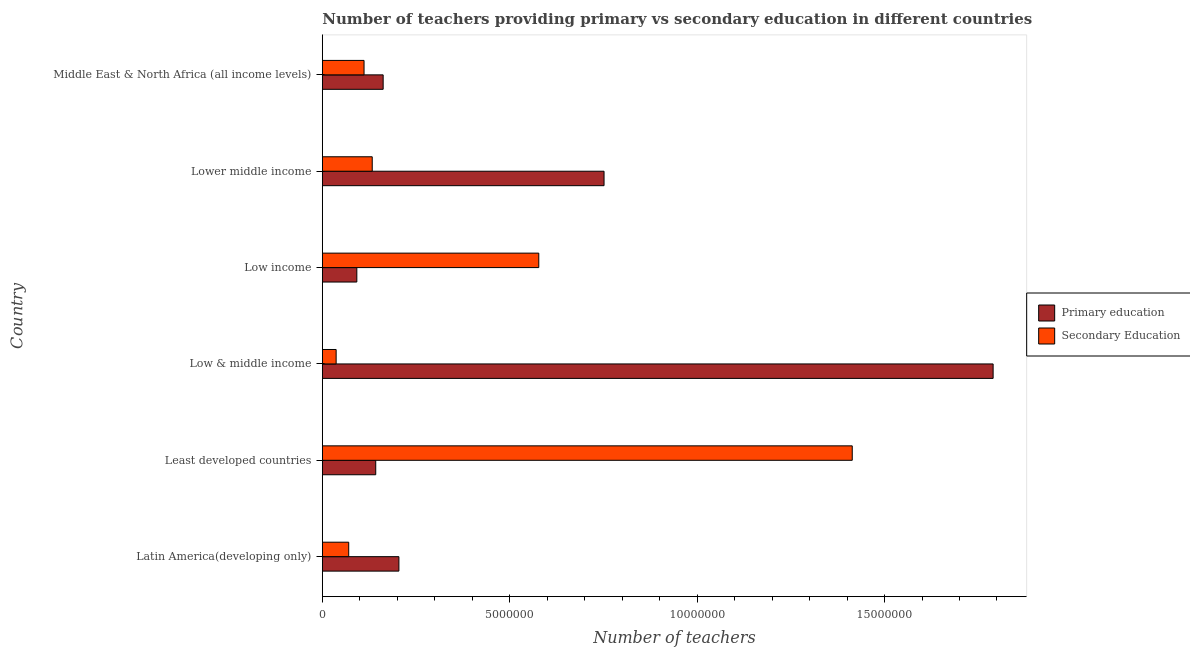How many different coloured bars are there?
Offer a terse response. 2. Are the number of bars on each tick of the Y-axis equal?
Make the answer very short. Yes. How many bars are there on the 3rd tick from the top?
Offer a very short reply. 2. How many bars are there on the 2nd tick from the bottom?
Make the answer very short. 2. What is the label of the 1st group of bars from the top?
Keep it short and to the point. Middle East & North Africa (all income levels). What is the number of primary teachers in Low & middle income?
Your response must be concise. 1.79e+07. Across all countries, what is the maximum number of secondary teachers?
Your answer should be very brief. 1.41e+07. Across all countries, what is the minimum number of secondary teachers?
Provide a short and direct response. 3.69e+05. In which country was the number of secondary teachers maximum?
Your response must be concise. Least developed countries. In which country was the number of secondary teachers minimum?
Give a very brief answer. Low & middle income. What is the total number of secondary teachers in the graph?
Keep it short and to the point. 2.34e+07. What is the difference between the number of primary teachers in Low & middle income and that in Middle East & North Africa (all income levels)?
Offer a very short reply. 1.63e+07. What is the difference between the number of primary teachers in Least developed countries and the number of secondary teachers in Lower middle income?
Keep it short and to the point. 9.36e+04. What is the average number of secondary teachers per country?
Provide a short and direct response. 3.91e+06. What is the difference between the number of primary teachers and number of secondary teachers in Middle East & North Africa (all income levels)?
Your response must be concise. 5.10e+05. In how many countries, is the number of secondary teachers greater than 1000000 ?
Your answer should be compact. 4. What is the ratio of the number of primary teachers in Low & middle income to that in Middle East & North Africa (all income levels)?
Provide a short and direct response. 11.03. What is the difference between the highest and the second highest number of secondary teachers?
Provide a short and direct response. 8.36e+06. What is the difference between the highest and the lowest number of primary teachers?
Give a very brief answer. 1.70e+07. In how many countries, is the number of primary teachers greater than the average number of primary teachers taken over all countries?
Offer a very short reply. 2. What does the 1st bar from the top in Low income represents?
Provide a short and direct response. Secondary Education. What does the 2nd bar from the bottom in Middle East & North Africa (all income levels) represents?
Offer a terse response. Secondary Education. How many bars are there?
Keep it short and to the point. 12. How many countries are there in the graph?
Keep it short and to the point. 6. Does the graph contain grids?
Your answer should be compact. No. Where does the legend appear in the graph?
Ensure brevity in your answer.  Center right. How are the legend labels stacked?
Keep it short and to the point. Vertical. What is the title of the graph?
Make the answer very short. Number of teachers providing primary vs secondary education in different countries. Does "Net National savings" appear as one of the legend labels in the graph?
Make the answer very short. No. What is the label or title of the X-axis?
Keep it short and to the point. Number of teachers. What is the label or title of the Y-axis?
Give a very brief answer. Country. What is the Number of teachers of Primary education in Latin America(developing only)?
Offer a terse response. 2.04e+06. What is the Number of teachers of Secondary Education in Latin America(developing only)?
Provide a succinct answer. 7.04e+05. What is the Number of teachers of Primary education in Least developed countries?
Provide a succinct answer. 1.43e+06. What is the Number of teachers in Secondary Education in Least developed countries?
Give a very brief answer. 1.41e+07. What is the Number of teachers in Primary education in Low & middle income?
Keep it short and to the point. 1.79e+07. What is the Number of teachers in Secondary Education in Low & middle income?
Keep it short and to the point. 3.69e+05. What is the Number of teachers in Primary education in Low income?
Your answer should be very brief. 9.20e+05. What is the Number of teachers of Secondary Education in Low income?
Your response must be concise. 5.78e+06. What is the Number of teachers in Primary education in Lower middle income?
Ensure brevity in your answer.  7.52e+06. What is the Number of teachers in Secondary Education in Lower middle income?
Provide a short and direct response. 1.33e+06. What is the Number of teachers in Primary education in Middle East & North Africa (all income levels)?
Offer a terse response. 1.62e+06. What is the Number of teachers of Secondary Education in Middle East & North Africa (all income levels)?
Your response must be concise. 1.11e+06. Across all countries, what is the maximum Number of teachers in Primary education?
Provide a short and direct response. 1.79e+07. Across all countries, what is the maximum Number of teachers in Secondary Education?
Provide a succinct answer. 1.41e+07. Across all countries, what is the minimum Number of teachers in Primary education?
Your answer should be very brief. 9.20e+05. Across all countries, what is the minimum Number of teachers in Secondary Education?
Ensure brevity in your answer.  3.69e+05. What is the total Number of teachers of Primary education in the graph?
Your answer should be very brief. 3.14e+07. What is the total Number of teachers in Secondary Education in the graph?
Your answer should be very brief. 2.34e+07. What is the difference between the Number of teachers in Primary education in Latin America(developing only) and that in Least developed countries?
Keep it short and to the point. 6.18e+05. What is the difference between the Number of teachers of Secondary Education in Latin America(developing only) and that in Least developed countries?
Offer a terse response. -1.34e+07. What is the difference between the Number of teachers of Primary education in Latin America(developing only) and that in Low & middle income?
Your response must be concise. -1.59e+07. What is the difference between the Number of teachers of Secondary Education in Latin America(developing only) and that in Low & middle income?
Make the answer very short. 3.36e+05. What is the difference between the Number of teachers in Primary education in Latin America(developing only) and that in Low income?
Your answer should be very brief. 1.12e+06. What is the difference between the Number of teachers of Secondary Education in Latin America(developing only) and that in Low income?
Provide a succinct answer. -5.07e+06. What is the difference between the Number of teachers in Primary education in Latin America(developing only) and that in Lower middle income?
Your answer should be compact. -5.47e+06. What is the difference between the Number of teachers of Secondary Education in Latin America(developing only) and that in Lower middle income?
Offer a terse response. -6.27e+05. What is the difference between the Number of teachers of Primary education in Latin America(developing only) and that in Middle East & North Africa (all income levels)?
Provide a short and direct response. 4.20e+05. What is the difference between the Number of teachers in Secondary Education in Latin America(developing only) and that in Middle East & North Africa (all income levels)?
Make the answer very short. -4.09e+05. What is the difference between the Number of teachers of Primary education in Least developed countries and that in Low & middle income?
Make the answer very short. -1.65e+07. What is the difference between the Number of teachers of Secondary Education in Least developed countries and that in Low & middle income?
Your answer should be compact. 1.38e+07. What is the difference between the Number of teachers of Primary education in Least developed countries and that in Low income?
Make the answer very short. 5.05e+05. What is the difference between the Number of teachers in Secondary Education in Least developed countries and that in Low income?
Offer a very short reply. 8.36e+06. What is the difference between the Number of teachers of Primary education in Least developed countries and that in Lower middle income?
Offer a very short reply. -6.09e+06. What is the difference between the Number of teachers in Secondary Education in Least developed countries and that in Lower middle income?
Your answer should be very brief. 1.28e+07. What is the difference between the Number of teachers of Primary education in Least developed countries and that in Middle East & North Africa (all income levels)?
Your response must be concise. -1.98e+05. What is the difference between the Number of teachers in Secondary Education in Least developed countries and that in Middle East & North Africa (all income levels)?
Your response must be concise. 1.30e+07. What is the difference between the Number of teachers in Primary education in Low & middle income and that in Low income?
Ensure brevity in your answer.  1.70e+07. What is the difference between the Number of teachers in Secondary Education in Low & middle income and that in Low income?
Give a very brief answer. -5.41e+06. What is the difference between the Number of teachers of Primary education in Low & middle income and that in Lower middle income?
Your response must be concise. 1.04e+07. What is the difference between the Number of teachers of Secondary Education in Low & middle income and that in Lower middle income?
Make the answer very short. -9.63e+05. What is the difference between the Number of teachers in Primary education in Low & middle income and that in Middle East & North Africa (all income levels)?
Your answer should be very brief. 1.63e+07. What is the difference between the Number of teachers in Secondary Education in Low & middle income and that in Middle East & North Africa (all income levels)?
Provide a short and direct response. -7.44e+05. What is the difference between the Number of teachers of Primary education in Low income and that in Lower middle income?
Offer a very short reply. -6.60e+06. What is the difference between the Number of teachers of Secondary Education in Low income and that in Lower middle income?
Give a very brief answer. 4.44e+06. What is the difference between the Number of teachers of Primary education in Low income and that in Middle East & North Africa (all income levels)?
Offer a terse response. -7.03e+05. What is the difference between the Number of teachers of Secondary Education in Low income and that in Middle East & North Africa (all income levels)?
Offer a very short reply. 4.66e+06. What is the difference between the Number of teachers in Primary education in Lower middle income and that in Middle East & North Africa (all income levels)?
Your response must be concise. 5.89e+06. What is the difference between the Number of teachers of Secondary Education in Lower middle income and that in Middle East & North Africa (all income levels)?
Make the answer very short. 2.18e+05. What is the difference between the Number of teachers of Primary education in Latin America(developing only) and the Number of teachers of Secondary Education in Least developed countries?
Offer a very short reply. -1.21e+07. What is the difference between the Number of teachers in Primary education in Latin America(developing only) and the Number of teachers in Secondary Education in Low & middle income?
Make the answer very short. 1.67e+06. What is the difference between the Number of teachers of Primary education in Latin America(developing only) and the Number of teachers of Secondary Education in Low income?
Provide a succinct answer. -3.73e+06. What is the difference between the Number of teachers of Primary education in Latin America(developing only) and the Number of teachers of Secondary Education in Lower middle income?
Your response must be concise. 7.12e+05. What is the difference between the Number of teachers of Primary education in Latin America(developing only) and the Number of teachers of Secondary Education in Middle East & North Africa (all income levels)?
Provide a short and direct response. 9.30e+05. What is the difference between the Number of teachers of Primary education in Least developed countries and the Number of teachers of Secondary Education in Low & middle income?
Give a very brief answer. 1.06e+06. What is the difference between the Number of teachers in Primary education in Least developed countries and the Number of teachers in Secondary Education in Low income?
Make the answer very short. -4.35e+06. What is the difference between the Number of teachers in Primary education in Least developed countries and the Number of teachers in Secondary Education in Lower middle income?
Offer a very short reply. 9.36e+04. What is the difference between the Number of teachers of Primary education in Least developed countries and the Number of teachers of Secondary Education in Middle East & North Africa (all income levels)?
Provide a succinct answer. 3.12e+05. What is the difference between the Number of teachers of Primary education in Low & middle income and the Number of teachers of Secondary Education in Low income?
Your answer should be very brief. 1.21e+07. What is the difference between the Number of teachers in Primary education in Low & middle income and the Number of teachers in Secondary Education in Lower middle income?
Offer a very short reply. 1.66e+07. What is the difference between the Number of teachers of Primary education in Low & middle income and the Number of teachers of Secondary Education in Middle East & North Africa (all income levels)?
Your answer should be compact. 1.68e+07. What is the difference between the Number of teachers of Primary education in Low income and the Number of teachers of Secondary Education in Lower middle income?
Ensure brevity in your answer.  -4.11e+05. What is the difference between the Number of teachers of Primary education in Low income and the Number of teachers of Secondary Education in Middle East & North Africa (all income levels)?
Your response must be concise. -1.93e+05. What is the difference between the Number of teachers of Primary education in Lower middle income and the Number of teachers of Secondary Education in Middle East & North Africa (all income levels)?
Your response must be concise. 6.40e+06. What is the average Number of teachers in Primary education per country?
Your answer should be compact. 5.24e+06. What is the average Number of teachers in Secondary Education per country?
Make the answer very short. 3.91e+06. What is the difference between the Number of teachers in Primary education and Number of teachers in Secondary Education in Latin America(developing only)?
Your response must be concise. 1.34e+06. What is the difference between the Number of teachers in Primary education and Number of teachers in Secondary Education in Least developed countries?
Make the answer very short. -1.27e+07. What is the difference between the Number of teachers of Primary education and Number of teachers of Secondary Education in Low & middle income?
Offer a terse response. 1.75e+07. What is the difference between the Number of teachers in Primary education and Number of teachers in Secondary Education in Low income?
Your answer should be very brief. -4.85e+06. What is the difference between the Number of teachers in Primary education and Number of teachers in Secondary Education in Lower middle income?
Ensure brevity in your answer.  6.19e+06. What is the difference between the Number of teachers in Primary education and Number of teachers in Secondary Education in Middle East & North Africa (all income levels)?
Keep it short and to the point. 5.10e+05. What is the ratio of the Number of teachers in Primary education in Latin America(developing only) to that in Least developed countries?
Your answer should be compact. 1.43. What is the ratio of the Number of teachers of Secondary Education in Latin America(developing only) to that in Least developed countries?
Offer a terse response. 0.05. What is the ratio of the Number of teachers in Primary education in Latin America(developing only) to that in Low & middle income?
Your answer should be very brief. 0.11. What is the ratio of the Number of teachers in Secondary Education in Latin America(developing only) to that in Low & middle income?
Make the answer very short. 1.91. What is the ratio of the Number of teachers in Primary education in Latin America(developing only) to that in Low income?
Your answer should be compact. 2.22. What is the ratio of the Number of teachers in Secondary Education in Latin America(developing only) to that in Low income?
Keep it short and to the point. 0.12. What is the ratio of the Number of teachers of Primary education in Latin America(developing only) to that in Lower middle income?
Keep it short and to the point. 0.27. What is the ratio of the Number of teachers in Secondary Education in Latin America(developing only) to that in Lower middle income?
Give a very brief answer. 0.53. What is the ratio of the Number of teachers of Primary education in Latin America(developing only) to that in Middle East & North Africa (all income levels)?
Provide a succinct answer. 1.26. What is the ratio of the Number of teachers in Secondary Education in Latin America(developing only) to that in Middle East & North Africa (all income levels)?
Offer a very short reply. 0.63. What is the ratio of the Number of teachers of Primary education in Least developed countries to that in Low & middle income?
Your answer should be very brief. 0.08. What is the ratio of the Number of teachers of Secondary Education in Least developed countries to that in Low & middle income?
Provide a short and direct response. 38.36. What is the ratio of the Number of teachers in Primary education in Least developed countries to that in Low income?
Your answer should be very brief. 1.55. What is the ratio of the Number of teachers in Secondary Education in Least developed countries to that in Low income?
Offer a very short reply. 2.45. What is the ratio of the Number of teachers of Primary education in Least developed countries to that in Lower middle income?
Your answer should be compact. 0.19. What is the ratio of the Number of teachers of Secondary Education in Least developed countries to that in Lower middle income?
Ensure brevity in your answer.  10.62. What is the ratio of the Number of teachers in Primary education in Least developed countries to that in Middle East & North Africa (all income levels)?
Keep it short and to the point. 0.88. What is the ratio of the Number of teachers in Secondary Education in Least developed countries to that in Middle East & North Africa (all income levels)?
Make the answer very short. 12.7. What is the ratio of the Number of teachers of Primary education in Low & middle income to that in Low income?
Offer a terse response. 19.44. What is the ratio of the Number of teachers of Secondary Education in Low & middle income to that in Low income?
Offer a terse response. 0.06. What is the ratio of the Number of teachers of Primary education in Low & middle income to that in Lower middle income?
Give a very brief answer. 2.38. What is the ratio of the Number of teachers in Secondary Education in Low & middle income to that in Lower middle income?
Your answer should be compact. 0.28. What is the ratio of the Number of teachers of Primary education in Low & middle income to that in Middle East & North Africa (all income levels)?
Make the answer very short. 11.03. What is the ratio of the Number of teachers in Secondary Education in Low & middle income to that in Middle East & North Africa (all income levels)?
Make the answer very short. 0.33. What is the ratio of the Number of teachers in Primary education in Low income to that in Lower middle income?
Your response must be concise. 0.12. What is the ratio of the Number of teachers of Secondary Education in Low income to that in Lower middle income?
Make the answer very short. 4.34. What is the ratio of the Number of teachers in Primary education in Low income to that in Middle East & North Africa (all income levels)?
Offer a terse response. 0.57. What is the ratio of the Number of teachers in Secondary Education in Low income to that in Middle East & North Africa (all income levels)?
Give a very brief answer. 5.19. What is the ratio of the Number of teachers in Primary education in Lower middle income to that in Middle East & North Africa (all income levels)?
Your answer should be very brief. 4.63. What is the ratio of the Number of teachers of Secondary Education in Lower middle income to that in Middle East & North Africa (all income levels)?
Your answer should be very brief. 1.2. What is the difference between the highest and the second highest Number of teachers of Primary education?
Offer a very short reply. 1.04e+07. What is the difference between the highest and the second highest Number of teachers of Secondary Education?
Your response must be concise. 8.36e+06. What is the difference between the highest and the lowest Number of teachers in Primary education?
Your answer should be very brief. 1.70e+07. What is the difference between the highest and the lowest Number of teachers of Secondary Education?
Offer a terse response. 1.38e+07. 